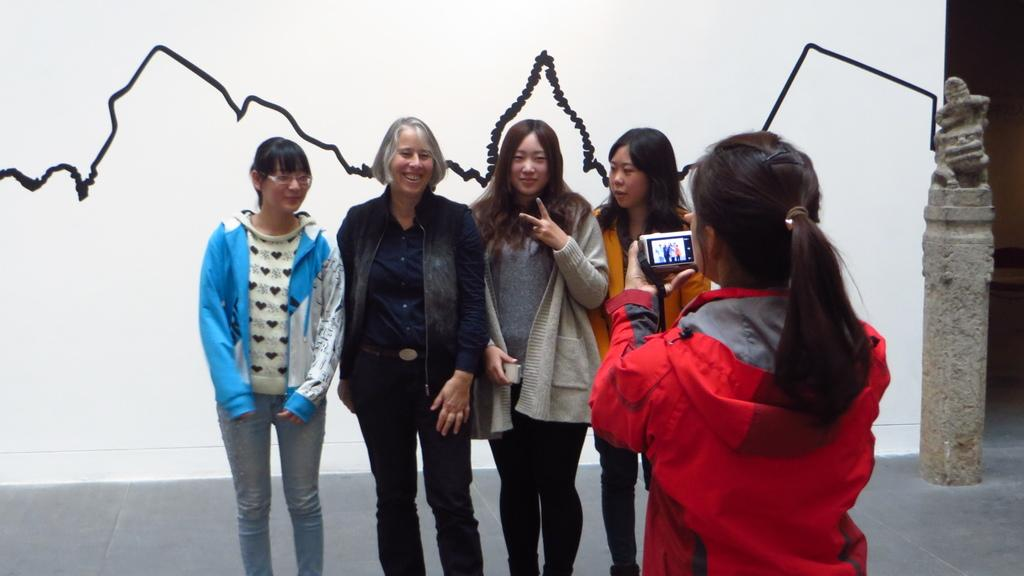What are the people in the image doing? The people in the image are standing. Can you describe the person holding an object in the image? A person is holding a camera in the image. What can be seen on the wall in the background of the image? There is a black line on a wall in the background of the image. What is located in the background of the image? There is a statue in the background of the image. What type of hair can be seen on the leg of the statue in the image? There is no hair or leg visible on the statue in the image. 